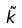<formula> <loc_0><loc_0><loc_500><loc_500>\tilde { k }</formula> 